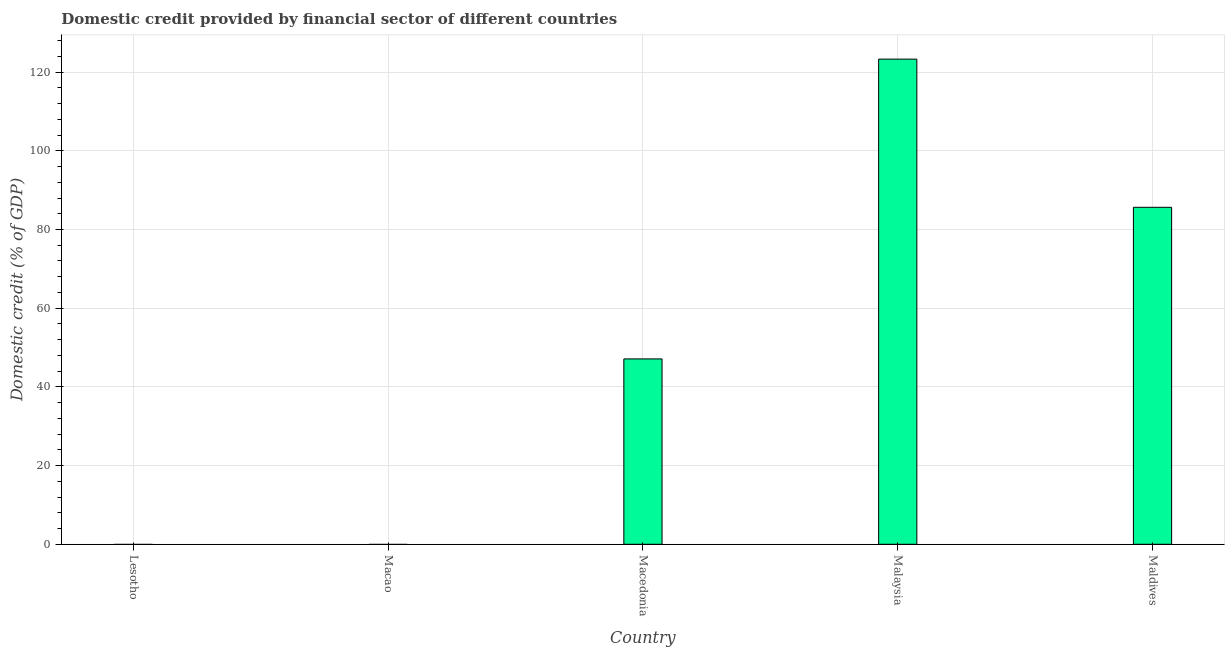Does the graph contain any zero values?
Provide a succinct answer. Yes. What is the title of the graph?
Provide a succinct answer. Domestic credit provided by financial sector of different countries. What is the label or title of the X-axis?
Your response must be concise. Country. What is the label or title of the Y-axis?
Keep it short and to the point. Domestic credit (% of GDP). What is the domestic credit provided by financial sector in Maldives?
Your response must be concise. 85.64. Across all countries, what is the maximum domestic credit provided by financial sector?
Provide a succinct answer. 123.29. In which country was the domestic credit provided by financial sector maximum?
Make the answer very short. Malaysia. What is the sum of the domestic credit provided by financial sector?
Your answer should be compact. 256.04. What is the difference between the domestic credit provided by financial sector in Macedonia and Maldives?
Give a very brief answer. -38.53. What is the average domestic credit provided by financial sector per country?
Provide a short and direct response. 51.21. What is the median domestic credit provided by financial sector?
Give a very brief answer. 47.11. What is the ratio of the domestic credit provided by financial sector in Macedonia to that in Malaysia?
Ensure brevity in your answer.  0.38. Is the domestic credit provided by financial sector in Macedonia less than that in Maldives?
Your response must be concise. Yes. What is the difference between the highest and the second highest domestic credit provided by financial sector?
Provide a short and direct response. 37.65. What is the difference between the highest and the lowest domestic credit provided by financial sector?
Your response must be concise. 123.29. Are all the bars in the graph horizontal?
Your answer should be compact. No. What is the Domestic credit (% of GDP) of Lesotho?
Offer a very short reply. 0. What is the Domestic credit (% of GDP) in Macedonia?
Keep it short and to the point. 47.11. What is the Domestic credit (% of GDP) in Malaysia?
Offer a very short reply. 123.29. What is the Domestic credit (% of GDP) in Maldives?
Keep it short and to the point. 85.64. What is the difference between the Domestic credit (% of GDP) in Macedonia and Malaysia?
Ensure brevity in your answer.  -76.18. What is the difference between the Domestic credit (% of GDP) in Macedonia and Maldives?
Give a very brief answer. -38.53. What is the difference between the Domestic credit (% of GDP) in Malaysia and Maldives?
Make the answer very short. 37.65. What is the ratio of the Domestic credit (% of GDP) in Macedonia to that in Malaysia?
Your answer should be very brief. 0.38. What is the ratio of the Domestic credit (% of GDP) in Macedonia to that in Maldives?
Your answer should be compact. 0.55. What is the ratio of the Domestic credit (% of GDP) in Malaysia to that in Maldives?
Offer a terse response. 1.44. 